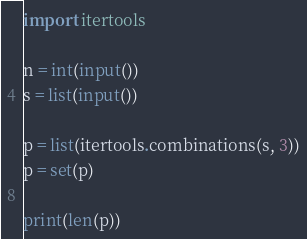<code> <loc_0><loc_0><loc_500><loc_500><_Python_>import itertools

n = int(input())
s = list(input())

p = list(itertools.combinations(s, 3))
p = set(p)

print(len(p))
</code> 